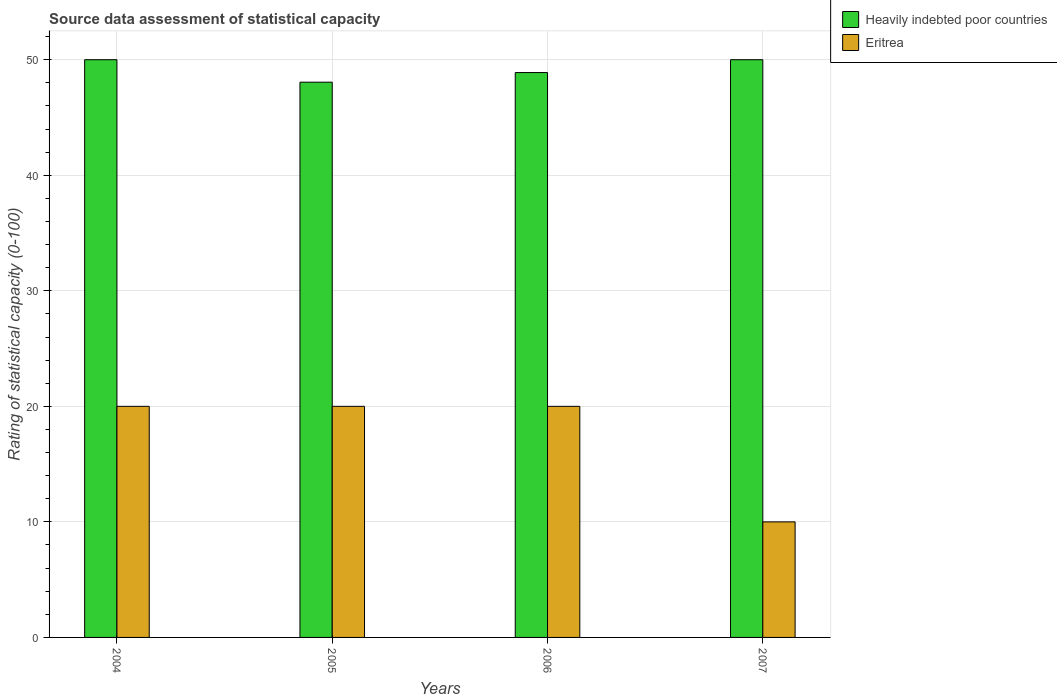Are the number of bars per tick equal to the number of legend labels?
Your answer should be very brief. Yes. Are the number of bars on each tick of the X-axis equal?
Your answer should be very brief. Yes. How many bars are there on the 4th tick from the left?
Offer a terse response. 2. What is the label of the 2nd group of bars from the left?
Give a very brief answer. 2005. In how many cases, is the number of bars for a given year not equal to the number of legend labels?
Ensure brevity in your answer.  0. What is the rating of statistical capacity in Heavily indebted poor countries in 2004?
Ensure brevity in your answer.  50. Across all years, what is the maximum rating of statistical capacity in Eritrea?
Your answer should be compact. 20. Across all years, what is the minimum rating of statistical capacity in Heavily indebted poor countries?
Give a very brief answer. 48.06. In which year was the rating of statistical capacity in Eritrea maximum?
Provide a short and direct response. 2004. What is the total rating of statistical capacity in Eritrea in the graph?
Ensure brevity in your answer.  70. What is the difference between the rating of statistical capacity in Heavily indebted poor countries in 2005 and that in 2007?
Your answer should be very brief. -1.94. What is the average rating of statistical capacity in Eritrea per year?
Provide a succinct answer. 17.5. In the year 2005, what is the difference between the rating of statistical capacity in Eritrea and rating of statistical capacity in Heavily indebted poor countries?
Provide a short and direct response. -28.06. What is the ratio of the rating of statistical capacity in Heavily indebted poor countries in 2005 to that in 2006?
Your response must be concise. 0.98. Is the difference between the rating of statistical capacity in Eritrea in 2005 and 2006 greater than the difference between the rating of statistical capacity in Heavily indebted poor countries in 2005 and 2006?
Give a very brief answer. Yes. What is the difference between the highest and the lowest rating of statistical capacity in Eritrea?
Provide a short and direct response. 10. In how many years, is the rating of statistical capacity in Heavily indebted poor countries greater than the average rating of statistical capacity in Heavily indebted poor countries taken over all years?
Offer a very short reply. 2. What does the 1st bar from the left in 2005 represents?
Your response must be concise. Heavily indebted poor countries. What does the 1st bar from the right in 2007 represents?
Give a very brief answer. Eritrea. Are all the bars in the graph horizontal?
Provide a short and direct response. No. What is the difference between two consecutive major ticks on the Y-axis?
Your response must be concise. 10. Does the graph contain any zero values?
Your answer should be compact. No. Where does the legend appear in the graph?
Keep it short and to the point. Top right. What is the title of the graph?
Provide a short and direct response. Source data assessment of statistical capacity. What is the label or title of the Y-axis?
Ensure brevity in your answer.  Rating of statistical capacity (0-100). What is the Rating of statistical capacity (0-100) of Heavily indebted poor countries in 2004?
Offer a terse response. 50. What is the Rating of statistical capacity (0-100) in Heavily indebted poor countries in 2005?
Provide a succinct answer. 48.06. What is the Rating of statistical capacity (0-100) of Heavily indebted poor countries in 2006?
Offer a terse response. 48.89. What is the Rating of statistical capacity (0-100) in Eritrea in 2006?
Offer a very short reply. 20. What is the Rating of statistical capacity (0-100) in Heavily indebted poor countries in 2007?
Offer a terse response. 50. What is the Rating of statistical capacity (0-100) of Eritrea in 2007?
Offer a very short reply. 10. Across all years, what is the maximum Rating of statistical capacity (0-100) of Heavily indebted poor countries?
Your answer should be compact. 50. Across all years, what is the minimum Rating of statistical capacity (0-100) in Heavily indebted poor countries?
Provide a short and direct response. 48.06. What is the total Rating of statistical capacity (0-100) in Heavily indebted poor countries in the graph?
Offer a terse response. 196.94. What is the total Rating of statistical capacity (0-100) in Eritrea in the graph?
Ensure brevity in your answer.  70. What is the difference between the Rating of statistical capacity (0-100) of Heavily indebted poor countries in 2004 and that in 2005?
Offer a very short reply. 1.94. What is the difference between the Rating of statistical capacity (0-100) of Heavily indebted poor countries in 2004 and that in 2006?
Provide a short and direct response. 1.11. What is the difference between the Rating of statistical capacity (0-100) of Eritrea in 2004 and that in 2007?
Offer a terse response. 10. What is the difference between the Rating of statistical capacity (0-100) of Heavily indebted poor countries in 2005 and that in 2007?
Provide a succinct answer. -1.94. What is the difference between the Rating of statistical capacity (0-100) in Heavily indebted poor countries in 2006 and that in 2007?
Give a very brief answer. -1.11. What is the difference between the Rating of statistical capacity (0-100) in Heavily indebted poor countries in 2004 and the Rating of statistical capacity (0-100) in Eritrea in 2007?
Make the answer very short. 40. What is the difference between the Rating of statistical capacity (0-100) of Heavily indebted poor countries in 2005 and the Rating of statistical capacity (0-100) of Eritrea in 2006?
Keep it short and to the point. 28.06. What is the difference between the Rating of statistical capacity (0-100) of Heavily indebted poor countries in 2005 and the Rating of statistical capacity (0-100) of Eritrea in 2007?
Your answer should be compact. 38.06. What is the difference between the Rating of statistical capacity (0-100) of Heavily indebted poor countries in 2006 and the Rating of statistical capacity (0-100) of Eritrea in 2007?
Ensure brevity in your answer.  38.89. What is the average Rating of statistical capacity (0-100) in Heavily indebted poor countries per year?
Provide a short and direct response. 49.24. In the year 2004, what is the difference between the Rating of statistical capacity (0-100) of Heavily indebted poor countries and Rating of statistical capacity (0-100) of Eritrea?
Offer a very short reply. 30. In the year 2005, what is the difference between the Rating of statistical capacity (0-100) of Heavily indebted poor countries and Rating of statistical capacity (0-100) of Eritrea?
Give a very brief answer. 28.06. In the year 2006, what is the difference between the Rating of statistical capacity (0-100) in Heavily indebted poor countries and Rating of statistical capacity (0-100) in Eritrea?
Offer a terse response. 28.89. In the year 2007, what is the difference between the Rating of statistical capacity (0-100) in Heavily indebted poor countries and Rating of statistical capacity (0-100) in Eritrea?
Make the answer very short. 40. What is the ratio of the Rating of statistical capacity (0-100) in Heavily indebted poor countries in 2004 to that in 2005?
Your response must be concise. 1.04. What is the ratio of the Rating of statistical capacity (0-100) of Heavily indebted poor countries in 2004 to that in 2006?
Make the answer very short. 1.02. What is the ratio of the Rating of statistical capacity (0-100) in Eritrea in 2004 to that in 2006?
Make the answer very short. 1. What is the ratio of the Rating of statistical capacity (0-100) in Eritrea in 2004 to that in 2007?
Ensure brevity in your answer.  2. What is the ratio of the Rating of statistical capacity (0-100) of Heavily indebted poor countries in 2005 to that in 2006?
Make the answer very short. 0.98. What is the ratio of the Rating of statistical capacity (0-100) in Heavily indebted poor countries in 2005 to that in 2007?
Offer a terse response. 0.96. What is the ratio of the Rating of statistical capacity (0-100) of Heavily indebted poor countries in 2006 to that in 2007?
Your answer should be compact. 0.98. What is the difference between the highest and the lowest Rating of statistical capacity (0-100) in Heavily indebted poor countries?
Offer a very short reply. 1.94. What is the difference between the highest and the lowest Rating of statistical capacity (0-100) in Eritrea?
Your answer should be compact. 10. 